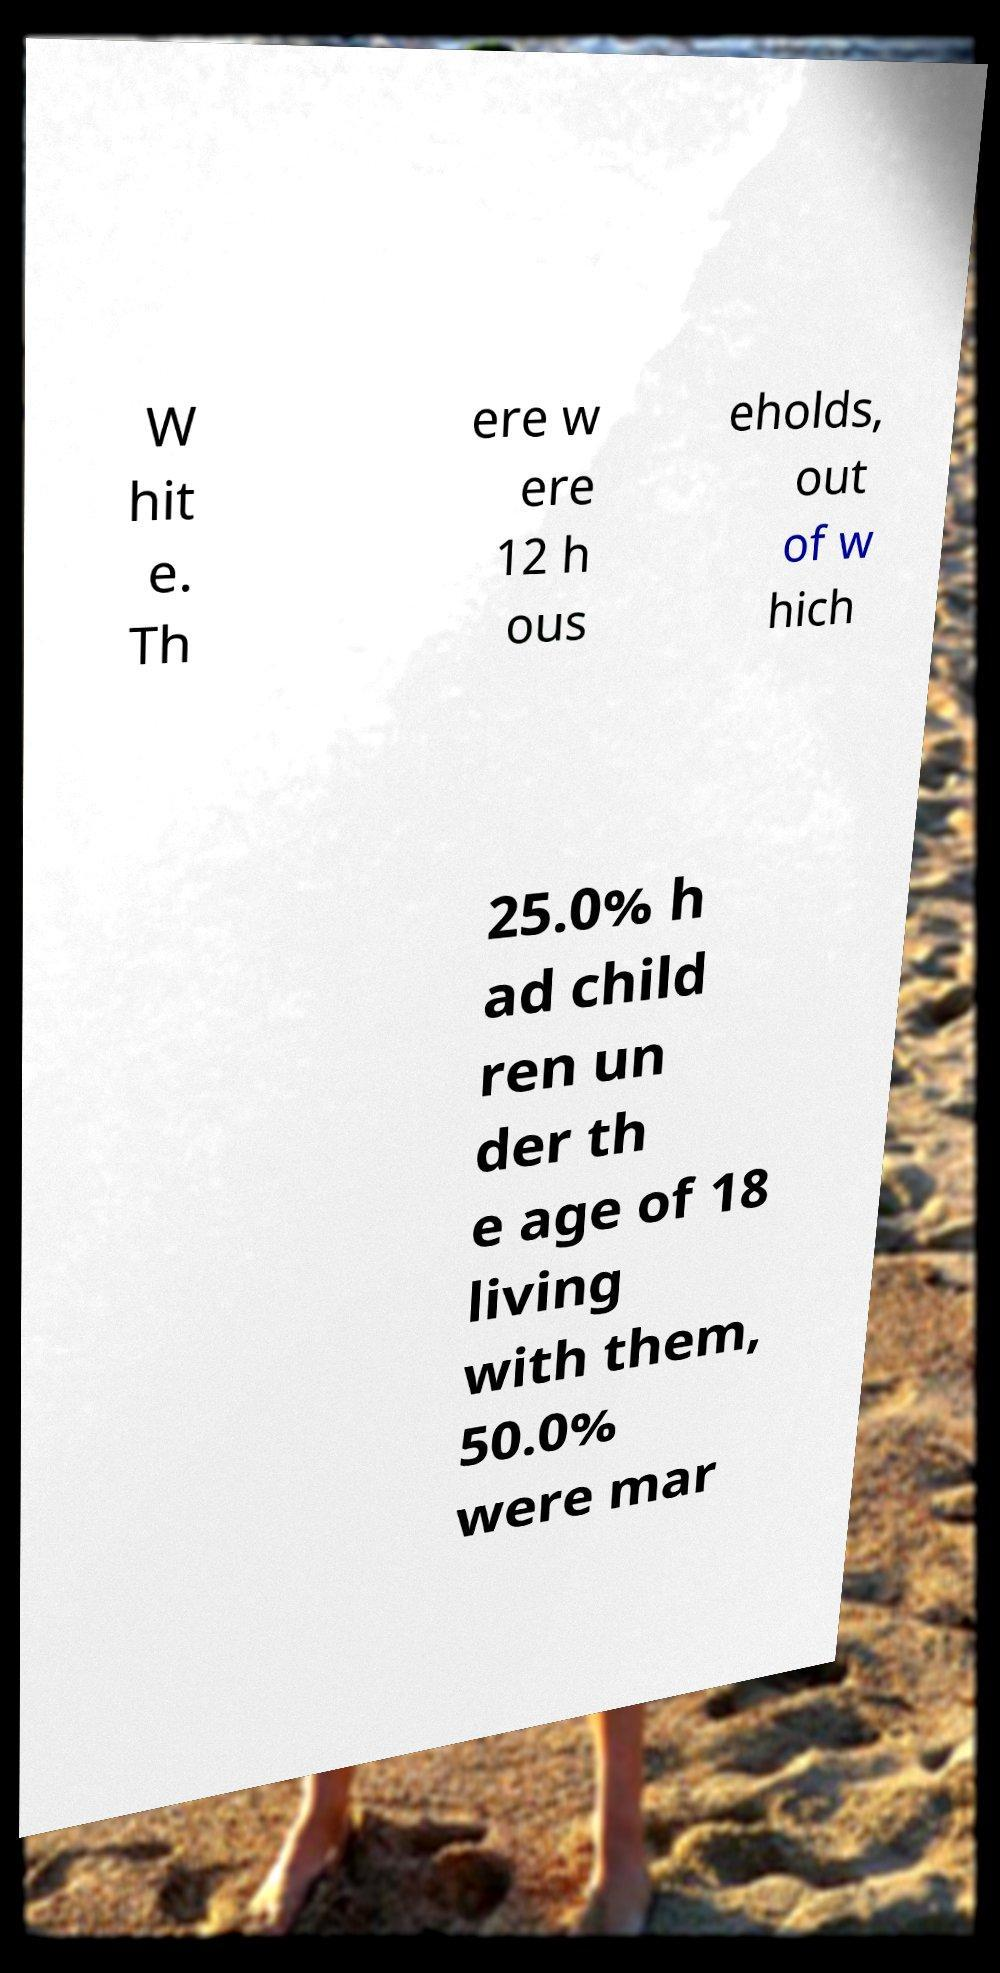Can you read and provide the text displayed in the image?This photo seems to have some interesting text. Can you extract and type it out for me? W hit e. Th ere w ere 12 h ous eholds, out of w hich 25.0% h ad child ren un der th e age of 18 living with them, 50.0% were mar 